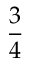<formula> <loc_0><loc_0><loc_500><loc_500>\frac { 3 } { 4 }</formula> 